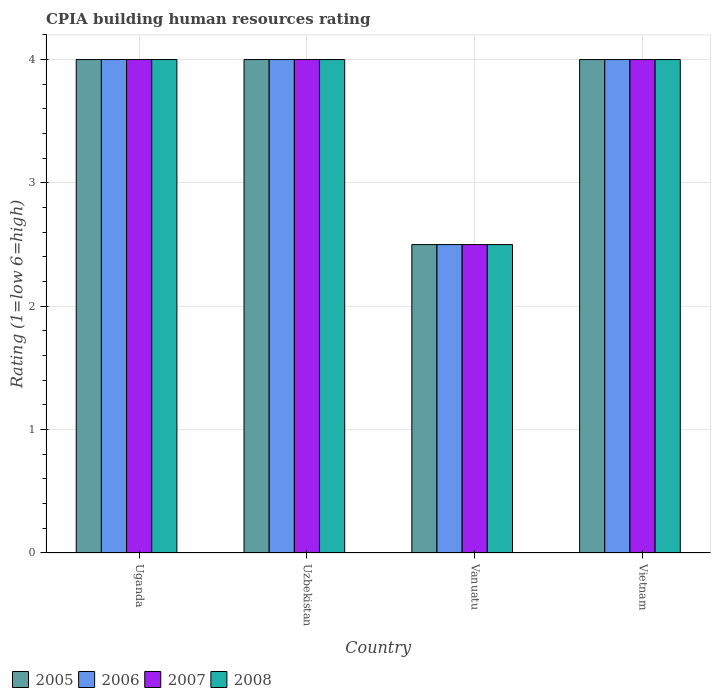How many different coloured bars are there?
Offer a very short reply. 4. What is the label of the 4th group of bars from the left?
Provide a succinct answer. Vietnam. What is the CPIA rating in 2007 in Vanuatu?
Make the answer very short. 2.5. Across all countries, what is the minimum CPIA rating in 2005?
Give a very brief answer. 2.5. In which country was the CPIA rating in 2008 maximum?
Offer a very short reply. Uganda. In which country was the CPIA rating in 2005 minimum?
Offer a terse response. Vanuatu. What is the total CPIA rating in 2006 in the graph?
Offer a terse response. 14.5. What is the average CPIA rating in 2006 per country?
Ensure brevity in your answer.  3.62. In how many countries, is the CPIA rating in 2007 greater than 2.6?
Your answer should be compact. 3. What is the ratio of the CPIA rating in 2008 in Uganda to that in Uzbekistan?
Offer a terse response. 1. What is the difference between the highest and the lowest CPIA rating in 2006?
Your answer should be compact. 1.5. In how many countries, is the CPIA rating in 2006 greater than the average CPIA rating in 2006 taken over all countries?
Make the answer very short. 3. Is it the case that in every country, the sum of the CPIA rating in 2005 and CPIA rating in 2008 is greater than the sum of CPIA rating in 2006 and CPIA rating in 2007?
Offer a very short reply. No. What does the 4th bar from the right in Uzbekistan represents?
Your response must be concise. 2005. How many bars are there?
Offer a very short reply. 16. Are all the bars in the graph horizontal?
Provide a short and direct response. No. Where does the legend appear in the graph?
Your answer should be very brief. Bottom left. What is the title of the graph?
Keep it short and to the point. CPIA building human resources rating. Does "1995" appear as one of the legend labels in the graph?
Offer a terse response. No. What is the label or title of the Y-axis?
Provide a succinct answer. Rating (1=low 6=high). What is the Rating (1=low 6=high) in 2005 in Uganda?
Provide a succinct answer. 4. What is the Rating (1=low 6=high) in 2008 in Uganda?
Offer a very short reply. 4. What is the Rating (1=low 6=high) of 2005 in Uzbekistan?
Provide a short and direct response. 4. What is the Rating (1=low 6=high) of 2007 in Uzbekistan?
Your answer should be very brief. 4. What is the Rating (1=low 6=high) of 2008 in Uzbekistan?
Provide a succinct answer. 4. What is the Rating (1=low 6=high) of 2006 in Vanuatu?
Offer a terse response. 2.5. What is the Rating (1=low 6=high) in 2008 in Vanuatu?
Ensure brevity in your answer.  2.5. What is the Rating (1=low 6=high) of 2007 in Vietnam?
Your answer should be compact. 4. Across all countries, what is the maximum Rating (1=low 6=high) of 2005?
Keep it short and to the point. 4. Across all countries, what is the maximum Rating (1=low 6=high) in 2006?
Ensure brevity in your answer.  4. Across all countries, what is the minimum Rating (1=low 6=high) in 2005?
Your answer should be compact. 2.5. Across all countries, what is the minimum Rating (1=low 6=high) in 2006?
Give a very brief answer. 2.5. What is the total Rating (1=low 6=high) in 2005 in the graph?
Your answer should be compact. 14.5. What is the total Rating (1=low 6=high) of 2007 in the graph?
Ensure brevity in your answer.  14.5. What is the difference between the Rating (1=low 6=high) of 2005 in Uganda and that in Uzbekistan?
Your response must be concise. 0. What is the difference between the Rating (1=low 6=high) of 2005 in Uganda and that in Vanuatu?
Offer a very short reply. 1.5. What is the difference between the Rating (1=low 6=high) in 2007 in Uganda and that in Vanuatu?
Your response must be concise. 1.5. What is the difference between the Rating (1=low 6=high) in 2006 in Uganda and that in Vietnam?
Make the answer very short. 0. What is the difference between the Rating (1=low 6=high) of 2008 in Uganda and that in Vietnam?
Keep it short and to the point. 0. What is the difference between the Rating (1=low 6=high) in 2005 in Uzbekistan and that in Vietnam?
Your answer should be very brief. 0. What is the difference between the Rating (1=low 6=high) of 2006 in Uzbekistan and that in Vietnam?
Your answer should be very brief. 0. What is the difference between the Rating (1=low 6=high) in 2007 in Uzbekistan and that in Vietnam?
Offer a terse response. 0. What is the difference between the Rating (1=low 6=high) of 2008 in Uzbekistan and that in Vietnam?
Ensure brevity in your answer.  0. What is the difference between the Rating (1=low 6=high) in 2005 in Vanuatu and that in Vietnam?
Your response must be concise. -1.5. What is the difference between the Rating (1=low 6=high) of 2006 in Vanuatu and that in Vietnam?
Keep it short and to the point. -1.5. What is the difference between the Rating (1=low 6=high) in 2007 in Vanuatu and that in Vietnam?
Your response must be concise. -1.5. What is the difference between the Rating (1=low 6=high) of 2005 in Uganda and the Rating (1=low 6=high) of 2007 in Uzbekistan?
Your answer should be very brief. 0. What is the difference between the Rating (1=low 6=high) in 2005 in Uganda and the Rating (1=low 6=high) in 2008 in Uzbekistan?
Your response must be concise. 0. What is the difference between the Rating (1=low 6=high) in 2006 in Uganda and the Rating (1=low 6=high) in 2007 in Uzbekistan?
Offer a terse response. 0. What is the difference between the Rating (1=low 6=high) in 2007 in Uganda and the Rating (1=low 6=high) in 2008 in Uzbekistan?
Your answer should be very brief. 0. What is the difference between the Rating (1=low 6=high) in 2005 in Uganda and the Rating (1=low 6=high) in 2008 in Vanuatu?
Make the answer very short. 1.5. What is the difference between the Rating (1=low 6=high) in 2006 in Uganda and the Rating (1=low 6=high) in 2007 in Vanuatu?
Offer a very short reply. 1.5. What is the difference between the Rating (1=low 6=high) of 2006 in Uganda and the Rating (1=low 6=high) of 2008 in Vanuatu?
Provide a short and direct response. 1.5. What is the difference between the Rating (1=low 6=high) in 2007 in Uganda and the Rating (1=low 6=high) in 2008 in Vanuatu?
Make the answer very short. 1.5. What is the difference between the Rating (1=low 6=high) of 2005 in Uganda and the Rating (1=low 6=high) of 2006 in Vietnam?
Give a very brief answer. 0. What is the difference between the Rating (1=low 6=high) in 2005 in Uganda and the Rating (1=low 6=high) in 2008 in Vietnam?
Keep it short and to the point. 0. What is the difference between the Rating (1=low 6=high) in 2006 in Uganda and the Rating (1=low 6=high) in 2007 in Vietnam?
Make the answer very short. 0. What is the difference between the Rating (1=low 6=high) in 2006 in Uganda and the Rating (1=low 6=high) in 2008 in Vietnam?
Your answer should be very brief. 0. What is the difference between the Rating (1=low 6=high) of 2007 in Uganda and the Rating (1=low 6=high) of 2008 in Vietnam?
Your answer should be very brief. 0. What is the difference between the Rating (1=low 6=high) in 2005 in Uzbekistan and the Rating (1=low 6=high) in 2006 in Vanuatu?
Your response must be concise. 1.5. What is the difference between the Rating (1=low 6=high) of 2005 in Uzbekistan and the Rating (1=low 6=high) of 2007 in Vanuatu?
Keep it short and to the point. 1.5. What is the difference between the Rating (1=low 6=high) of 2006 in Uzbekistan and the Rating (1=low 6=high) of 2008 in Vanuatu?
Your response must be concise. 1.5. What is the difference between the Rating (1=low 6=high) of 2005 in Uzbekistan and the Rating (1=low 6=high) of 2006 in Vietnam?
Your answer should be compact. 0. What is the difference between the Rating (1=low 6=high) in 2005 in Uzbekistan and the Rating (1=low 6=high) in 2007 in Vietnam?
Your answer should be very brief. 0. What is the difference between the Rating (1=low 6=high) of 2006 in Uzbekistan and the Rating (1=low 6=high) of 2007 in Vietnam?
Your answer should be compact. 0. What is the difference between the Rating (1=low 6=high) of 2006 in Uzbekistan and the Rating (1=low 6=high) of 2008 in Vietnam?
Make the answer very short. 0. What is the difference between the Rating (1=low 6=high) in 2007 in Uzbekistan and the Rating (1=low 6=high) in 2008 in Vietnam?
Provide a succinct answer. 0. What is the difference between the Rating (1=low 6=high) of 2005 in Vanuatu and the Rating (1=low 6=high) of 2006 in Vietnam?
Offer a terse response. -1.5. What is the difference between the Rating (1=low 6=high) of 2006 in Vanuatu and the Rating (1=low 6=high) of 2007 in Vietnam?
Your answer should be compact. -1.5. What is the average Rating (1=low 6=high) in 2005 per country?
Give a very brief answer. 3.62. What is the average Rating (1=low 6=high) of 2006 per country?
Provide a short and direct response. 3.62. What is the average Rating (1=low 6=high) in 2007 per country?
Your answer should be compact. 3.62. What is the average Rating (1=low 6=high) in 2008 per country?
Provide a short and direct response. 3.62. What is the difference between the Rating (1=low 6=high) in 2006 and Rating (1=low 6=high) in 2007 in Uganda?
Your answer should be compact. 0. What is the difference between the Rating (1=low 6=high) of 2005 and Rating (1=low 6=high) of 2007 in Uzbekistan?
Offer a terse response. 0. What is the difference between the Rating (1=low 6=high) of 2006 and Rating (1=low 6=high) of 2008 in Uzbekistan?
Keep it short and to the point. 0. What is the difference between the Rating (1=low 6=high) of 2007 and Rating (1=low 6=high) of 2008 in Vanuatu?
Your answer should be compact. 0. What is the difference between the Rating (1=low 6=high) of 2005 and Rating (1=low 6=high) of 2007 in Vietnam?
Offer a terse response. 0. What is the difference between the Rating (1=low 6=high) of 2006 and Rating (1=low 6=high) of 2007 in Vietnam?
Make the answer very short. 0. What is the difference between the Rating (1=low 6=high) of 2007 and Rating (1=low 6=high) of 2008 in Vietnam?
Your response must be concise. 0. What is the ratio of the Rating (1=low 6=high) of 2006 in Uganda to that in Uzbekistan?
Keep it short and to the point. 1. What is the ratio of the Rating (1=low 6=high) of 2005 in Uganda to that in Vanuatu?
Make the answer very short. 1.6. What is the ratio of the Rating (1=low 6=high) in 2007 in Uganda to that in Vanuatu?
Your answer should be compact. 1.6. What is the ratio of the Rating (1=low 6=high) of 2008 in Uganda to that in Vanuatu?
Your response must be concise. 1.6. What is the ratio of the Rating (1=low 6=high) of 2006 in Uganda to that in Vietnam?
Your answer should be compact. 1. What is the ratio of the Rating (1=low 6=high) in 2005 in Uzbekistan to that in Vietnam?
Your response must be concise. 1. What is the ratio of the Rating (1=low 6=high) of 2006 in Uzbekistan to that in Vietnam?
Provide a succinct answer. 1. What is the ratio of the Rating (1=low 6=high) of 2008 in Uzbekistan to that in Vietnam?
Provide a succinct answer. 1. What is the ratio of the Rating (1=low 6=high) in 2007 in Vanuatu to that in Vietnam?
Keep it short and to the point. 0.62. What is the difference between the highest and the second highest Rating (1=low 6=high) in 2005?
Your answer should be very brief. 0. What is the difference between the highest and the second highest Rating (1=low 6=high) of 2007?
Provide a short and direct response. 0. What is the difference between the highest and the second highest Rating (1=low 6=high) of 2008?
Your answer should be compact. 0. What is the difference between the highest and the lowest Rating (1=low 6=high) in 2007?
Your response must be concise. 1.5. What is the difference between the highest and the lowest Rating (1=low 6=high) of 2008?
Your answer should be very brief. 1.5. 